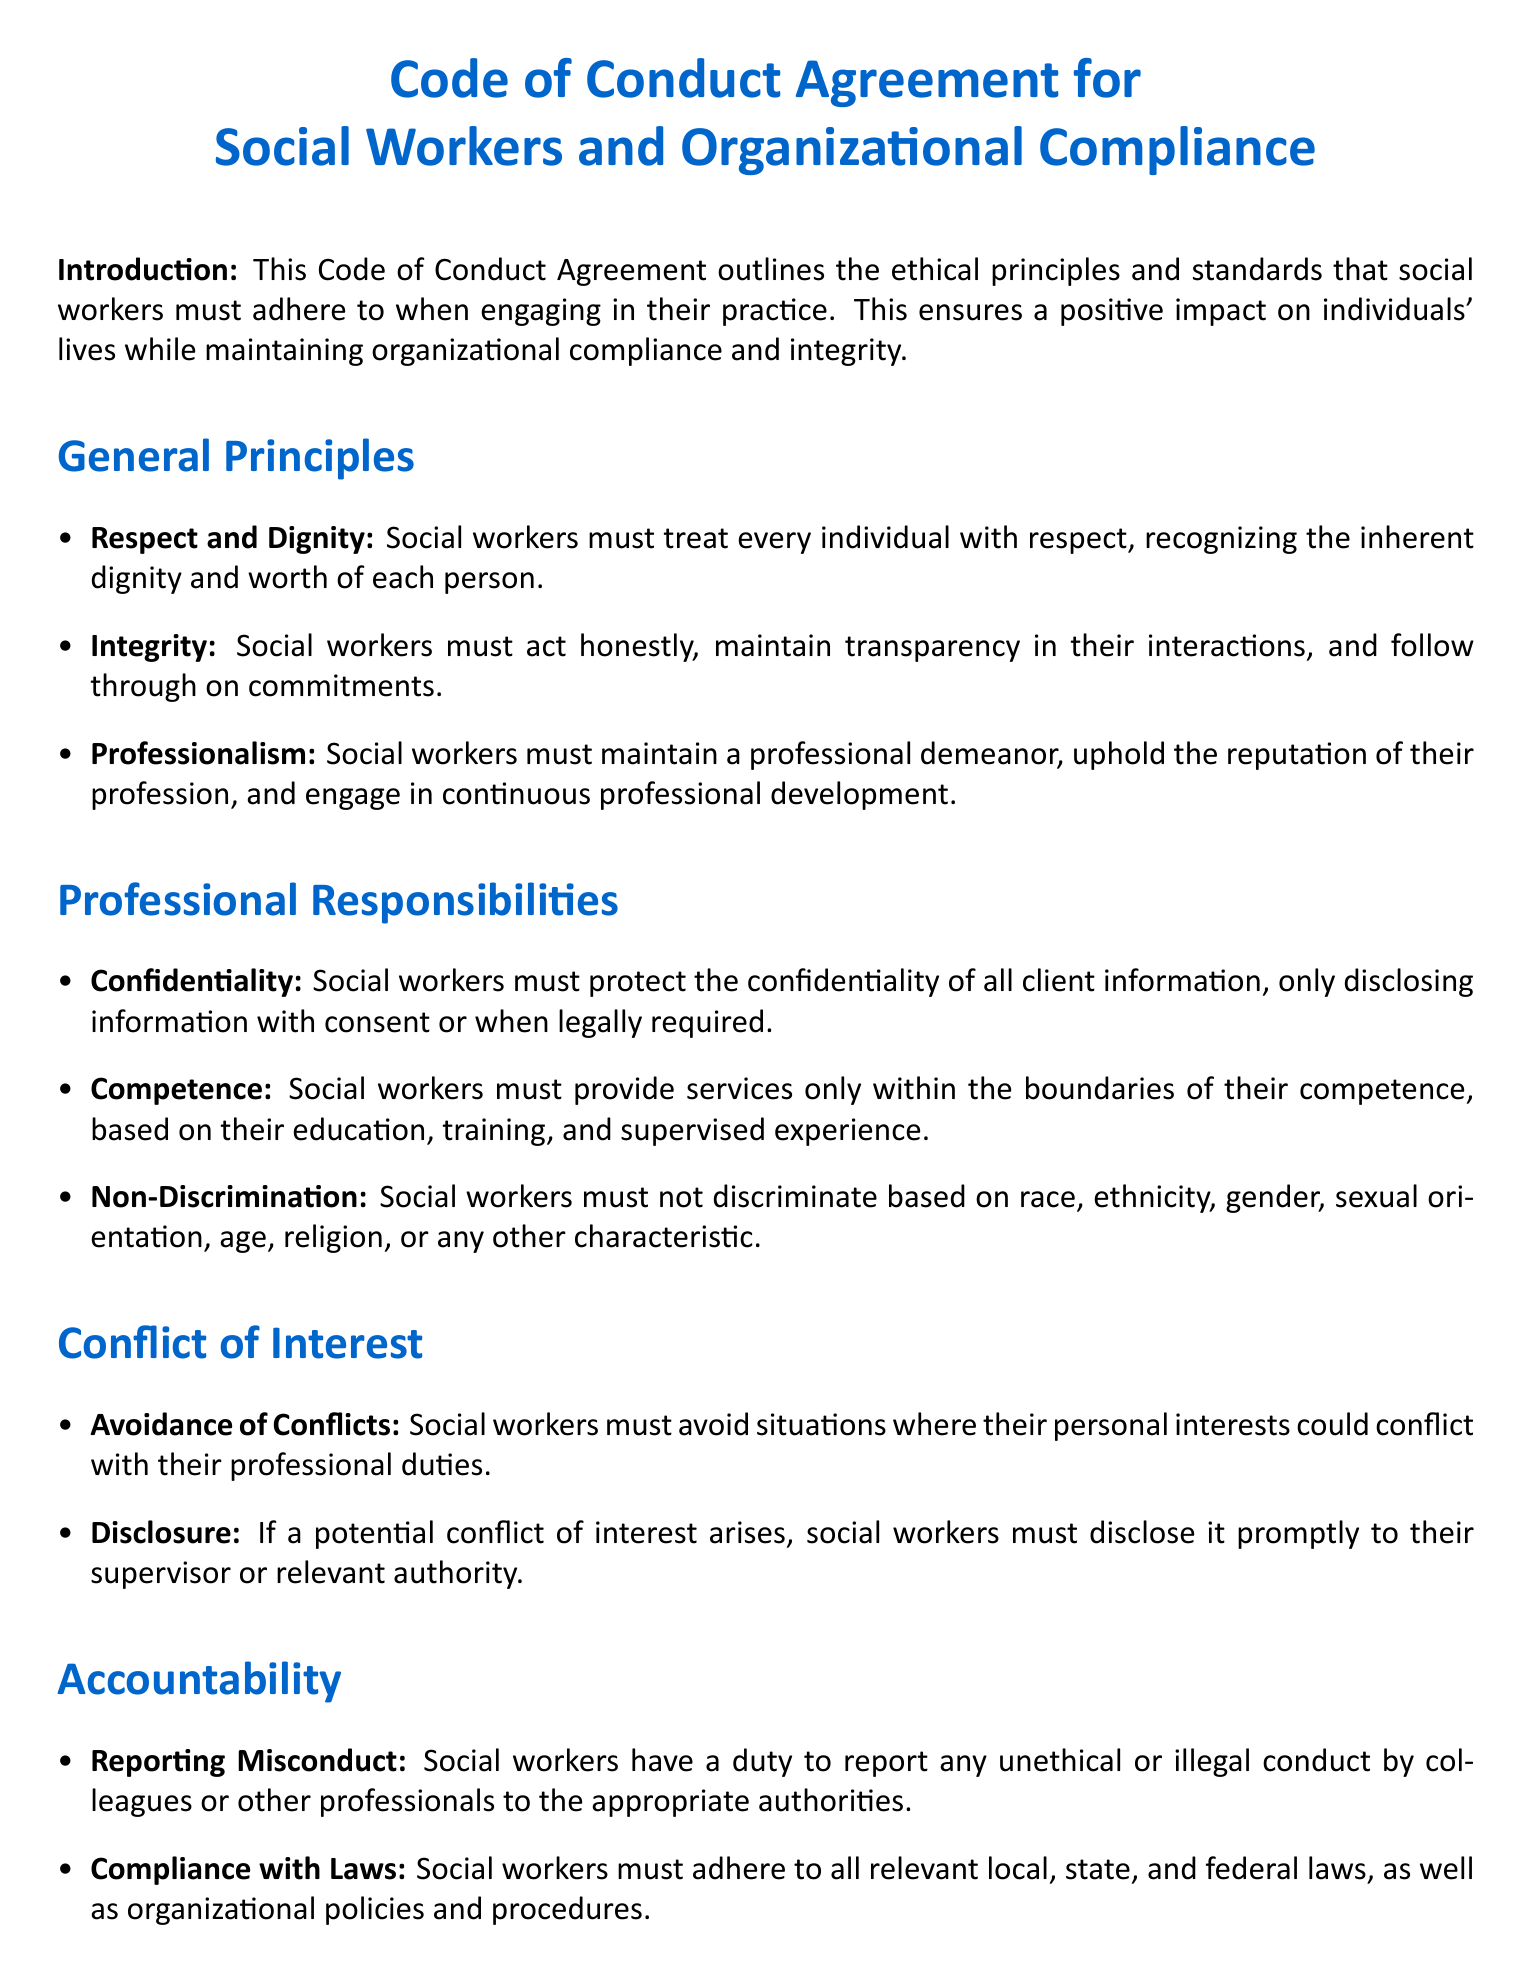what is the main purpose of the Code of Conduct Agreement? The purpose of the Code of Conduct Agreement is to outline ethical principles and standards that social workers must adhere to in their practice.
Answer: ethical principles and standards how many general principles are listed in the agreement? The number of general principles is stated in the section titled "General Principles".
Answer: three what should social workers do if they encounter a conflict of interest? The document states that social workers must disclose a potential conflict of interest promptly to their supervisor or relevant authority.
Answer: disclose what is one of the professional responsibilities of social workers? The agreement outlines several responsibilities including confidentiality, competence, and non-discrimination.
Answer: confidentiality who confirms the understanding of the agreement by the social worker? The role responsible for confirming understanding is specified in the "Signatures" section.
Answer: Supervisor 